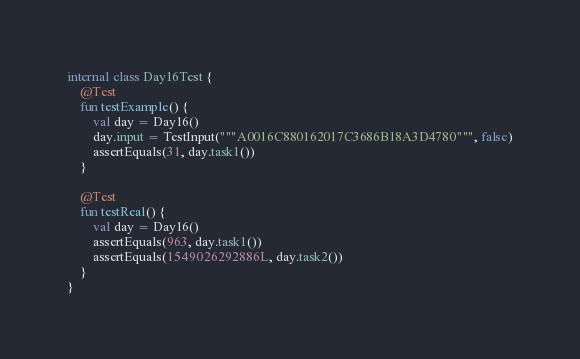<code> <loc_0><loc_0><loc_500><loc_500><_Kotlin_>
internal class Day16Test {
    @Test
    fun testExample() {
        val day = Day16()
        day.input = TestInput("""A0016C880162017C3686B18A3D4780""", false)
        assertEquals(31, day.task1())
    }

    @Test
    fun testReal() {
        val day = Day16()
        assertEquals(963, day.task1())
        assertEquals(1549026292886L, day.task2())
    }
}</code> 